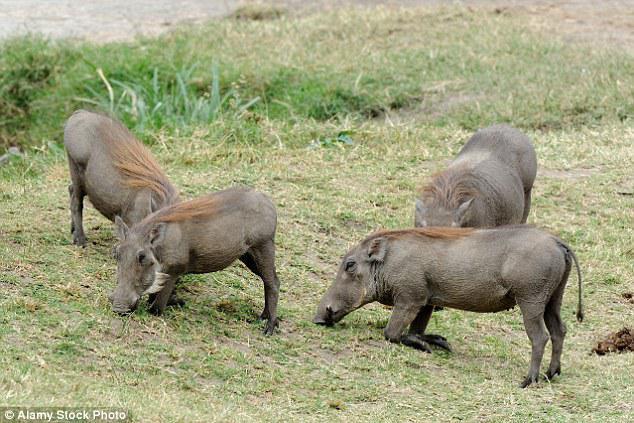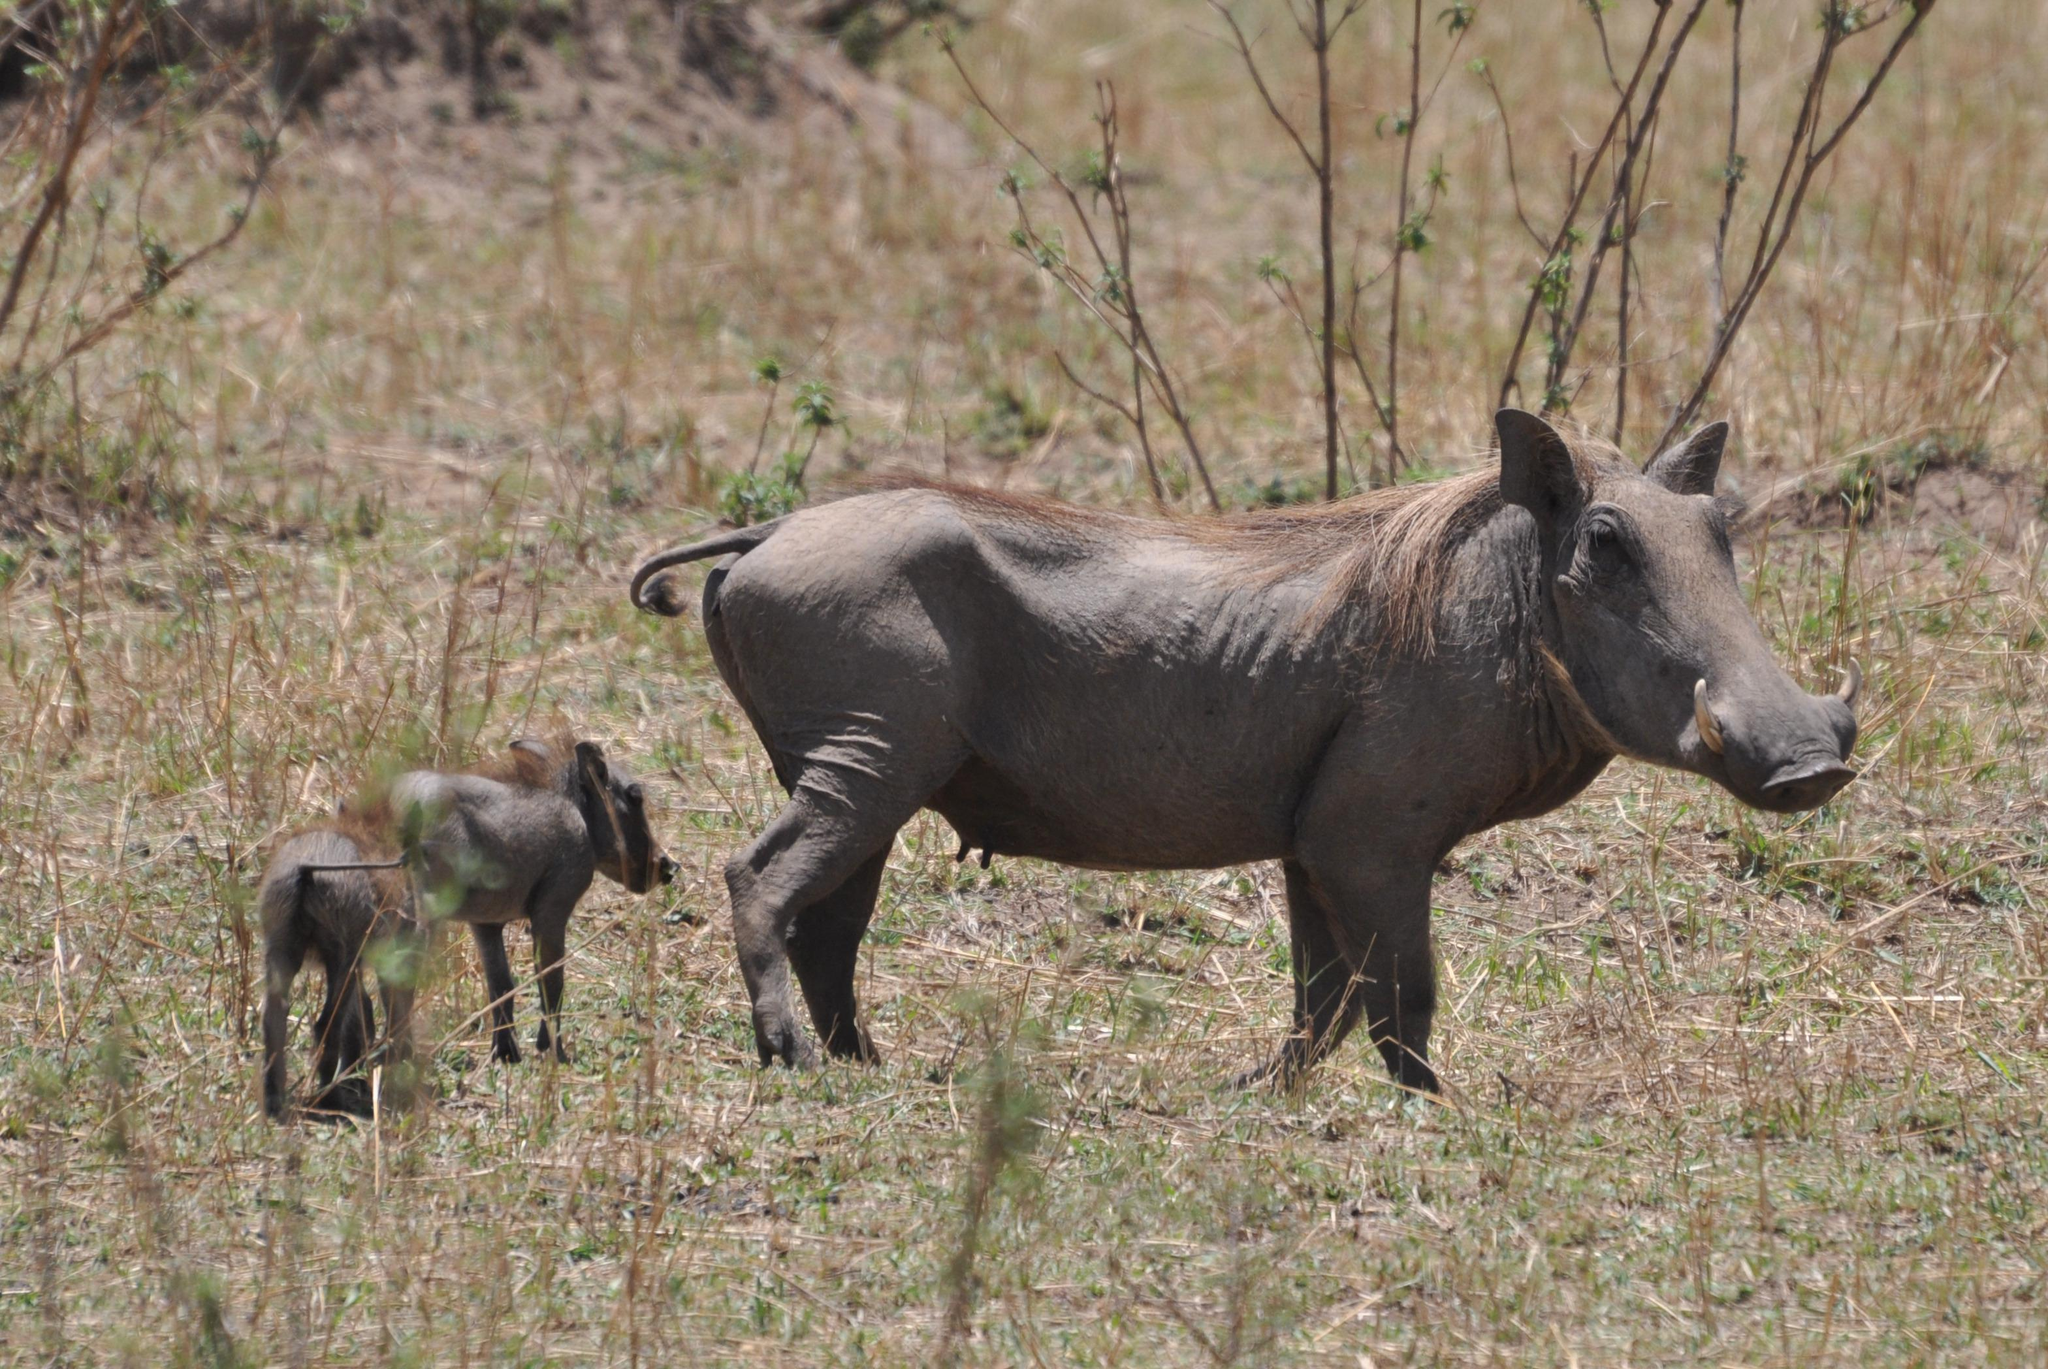The first image is the image on the left, the second image is the image on the right. Assess this claim about the two images: "An image includes a warthog that is standing with its front knees on the ground.". Correct or not? Answer yes or no. Yes. 